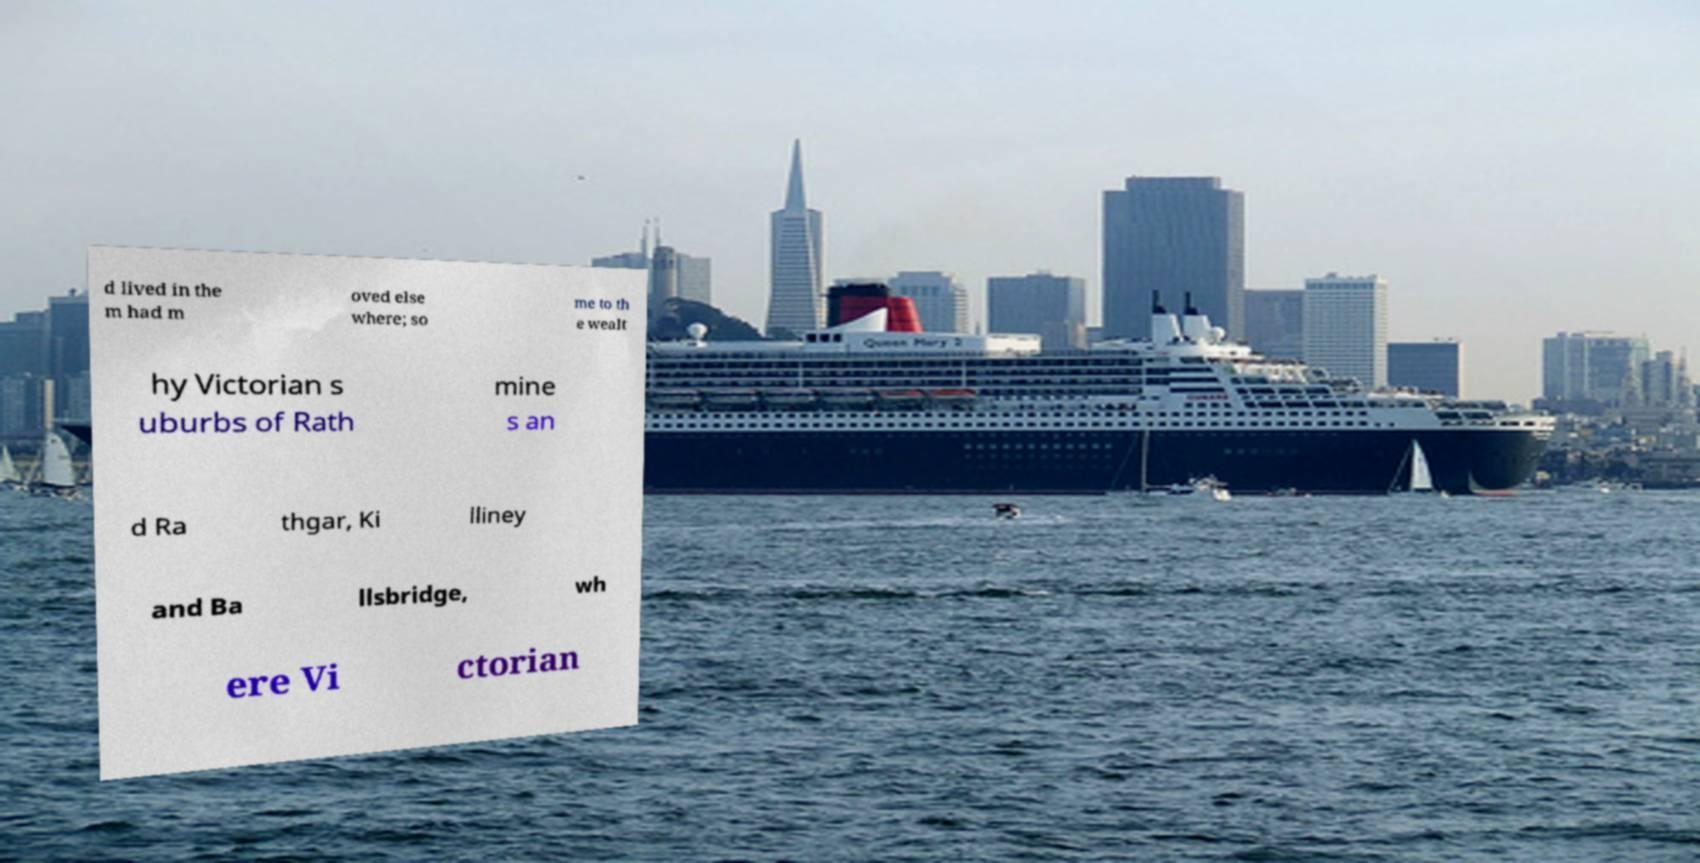Please identify and transcribe the text found in this image. d lived in the m had m oved else where; so me to th e wealt hy Victorian s uburbs of Rath mine s an d Ra thgar, Ki lliney and Ba llsbridge, wh ere Vi ctorian 